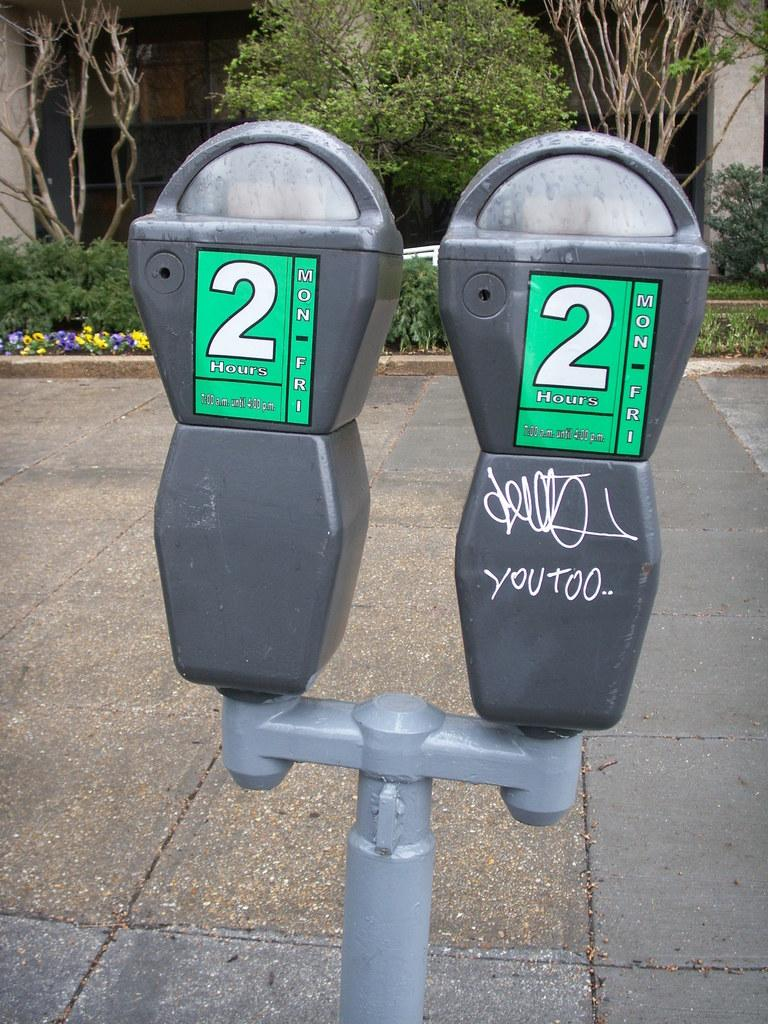<image>
Offer a succinct explanation of the picture presented. a couple of meters with the number 2 on them 